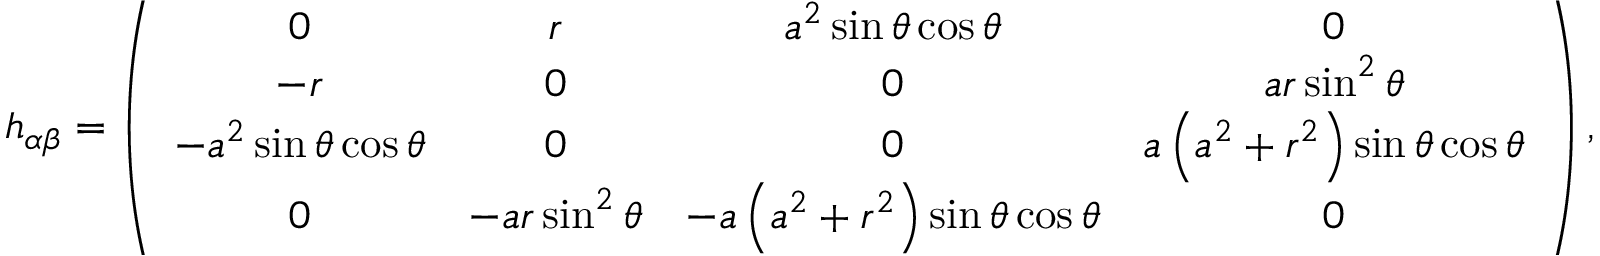Convert formula to latex. <formula><loc_0><loc_0><loc_500><loc_500>h _ { \alpha \beta } = \left ( \begin{array} { c c c c } { 0 } & { r } & { a ^ { 2 } \sin \theta \cos \theta } & { 0 } \\ { - r } & { 0 } & { 0 } & { a r \sin ^ { 2 } \theta } \\ { - a ^ { 2 } \sin \theta \cos \theta } & { 0 } & { 0 } & { a \left ( a ^ { 2 } + r ^ { 2 } \right ) \sin \theta \cos \theta } \\ { 0 } & { - a r \sin ^ { 2 } \theta } & { - a \left ( a ^ { 2 } + r ^ { 2 } \right ) \sin \theta \cos \theta } & { 0 } \end{array} \right ) ,</formula> 